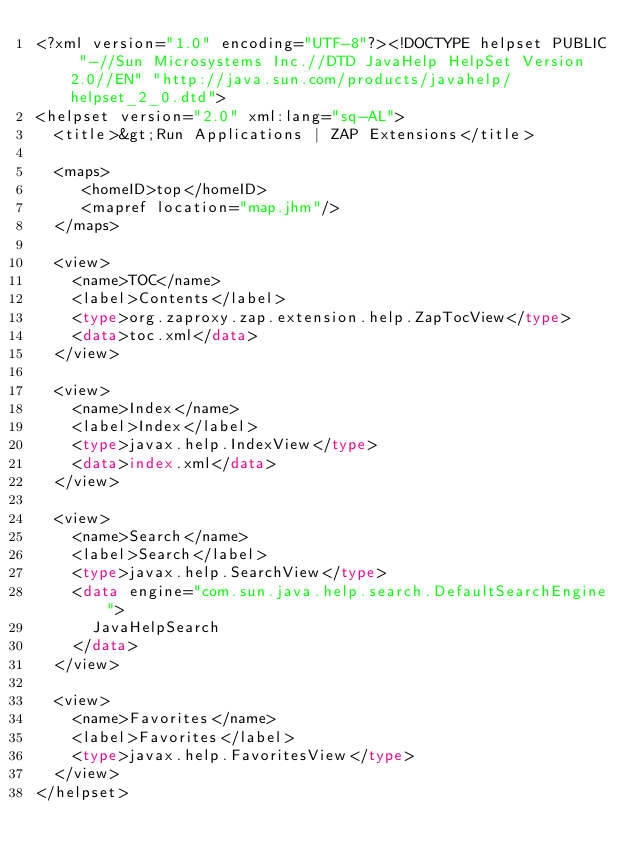Convert code to text. <code><loc_0><loc_0><loc_500><loc_500><_Haskell_><?xml version="1.0" encoding="UTF-8"?><!DOCTYPE helpset PUBLIC "-//Sun Microsystems Inc.//DTD JavaHelp HelpSet Version 2.0//EN" "http://java.sun.com/products/javahelp/helpset_2_0.dtd">
<helpset version="2.0" xml:lang="sq-AL">
  <title>&gt;Run Applications | ZAP Extensions</title>

  <maps>
     <homeID>top</homeID>
     <mapref location="map.jhm"/>
  </maps>

  <view>
    <name>TOC</name>
    <label>Contents</label>
    <type>org.zaproxy.zap.extension.help.ZapTocView</type>
    <data>toc.xml</data>
  </view>

  <view>
    <name>Index</name>
    <label>Index</label>
    <type>javax.help.IndexView</type>
    <data>index.xml</data>
  </view>

  <view>
    <name>Search</name>
    <label>Search</label>
    <type>javax.help.SearchView</type>
    <data engine="com.sun.java.help.search.DefaultSearchEngine">
      JavaHelpSearch
    </data>
  </view>

  <view>
    <name>Favorites</name>
    <label>Favorites</label>
    <type>javax.help.FavoritesView</type>
  </view>
</helpset></code> 